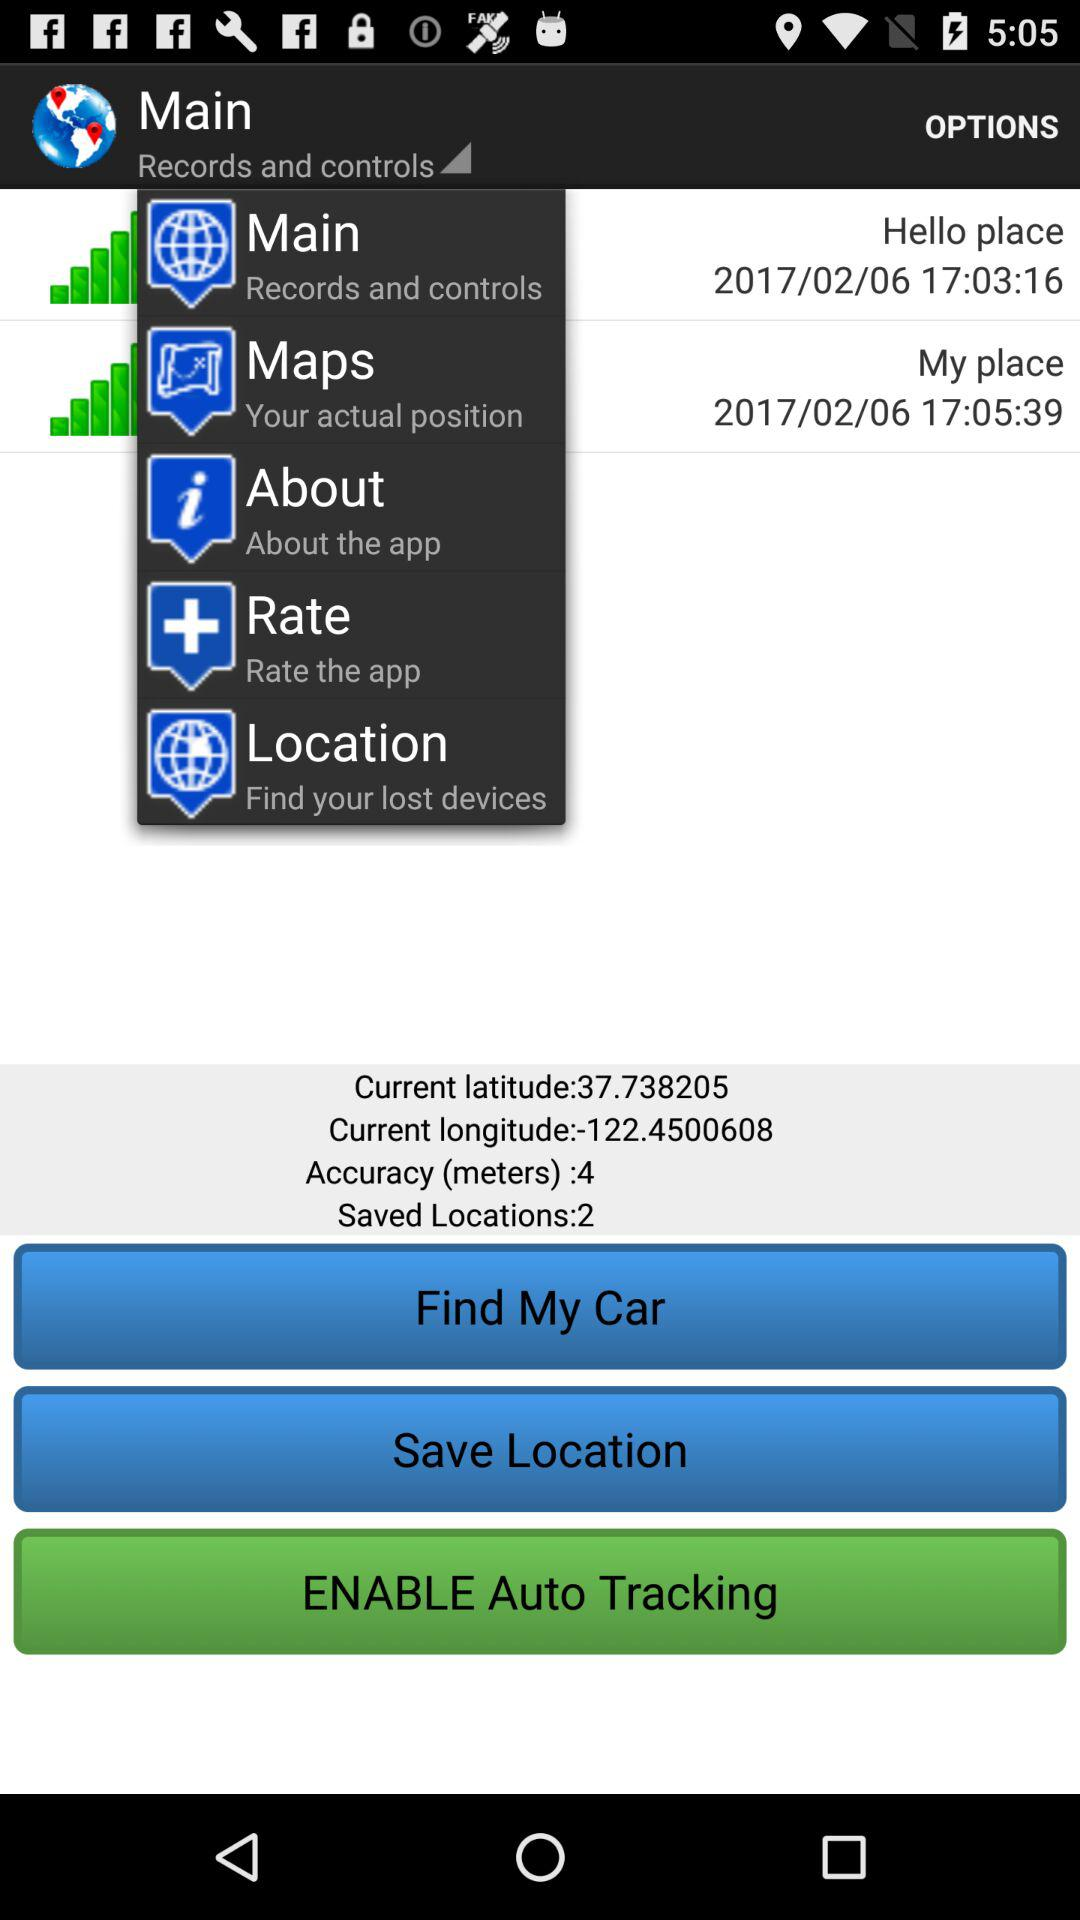How many locations have been saved?
Answer the question using a single word or phrase. 2 